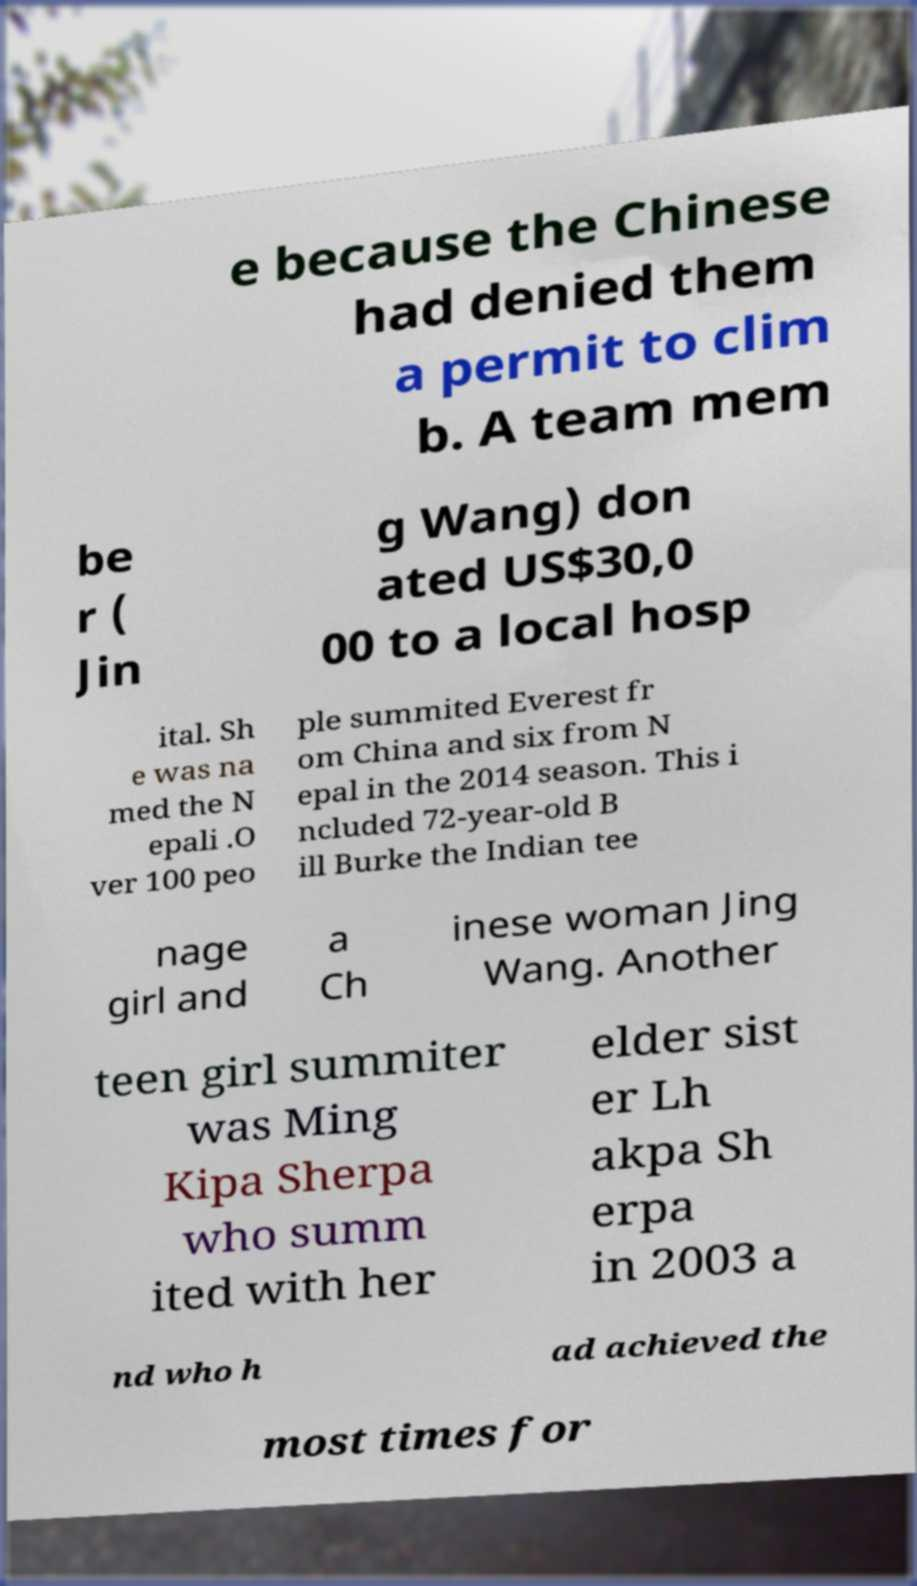Please identify and transcribe the text found in this image. e because the Chinese had denied them a permit to clim b. A team mem be r ( Jin g Wang) don ated US$30,0 00 to a local hosp ital. Sh e was na med the N epali .O ver 100 peo ple summited Everest fr om China and six from N epal in the 2014 season. This i ncluded 72-year-old B ill Burke the Indian tee nage girl and a Ch inese woman Jing Wang. Another teen girl summiter was Ming Kipa Sherpa who summ ited with her elder sist er Lh akpa Sh erpa in 2003 a nd who h ad achieved the most times for 